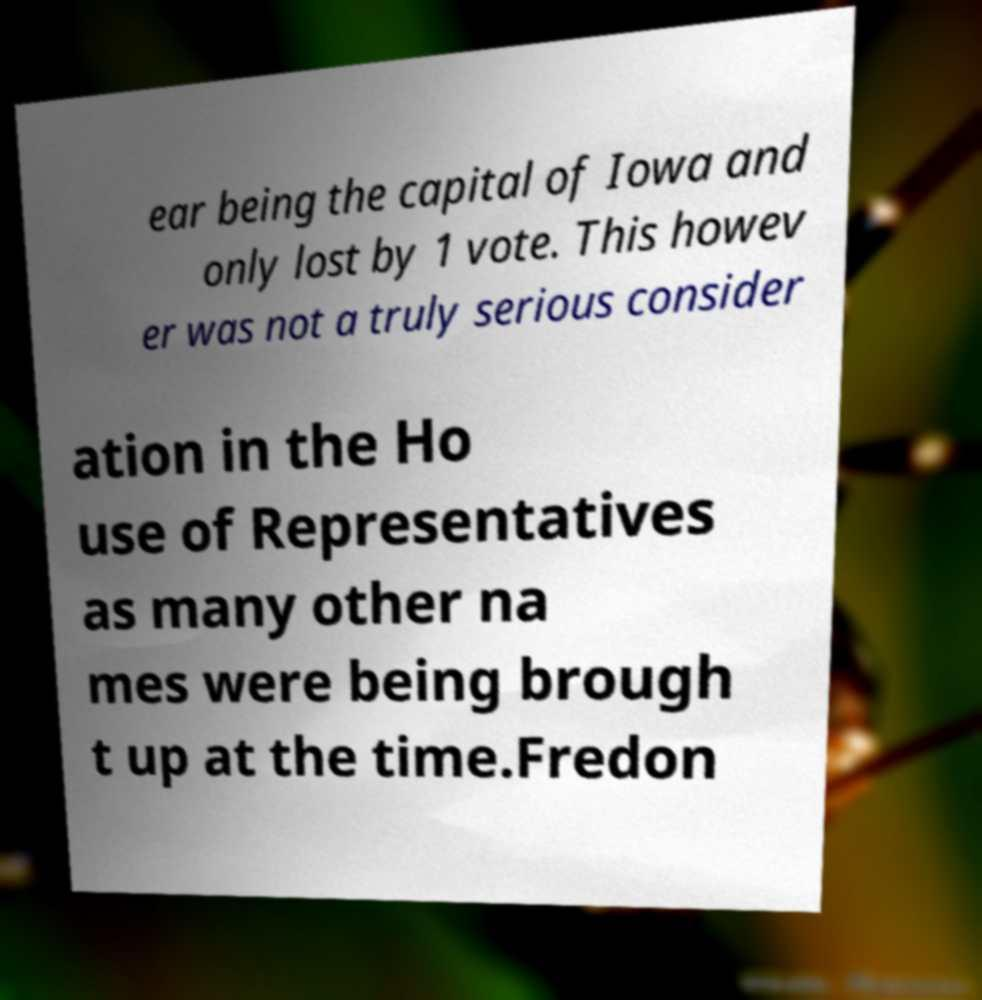Could you assist in decoding the text presented in this image and type it out clearly? ear being the capital of Iowa and only lost by 1 vote. This howev er was not a truly serious consider ation in the Ho use of Representatives as many other na mes were being brough t up at the time.Fredon 